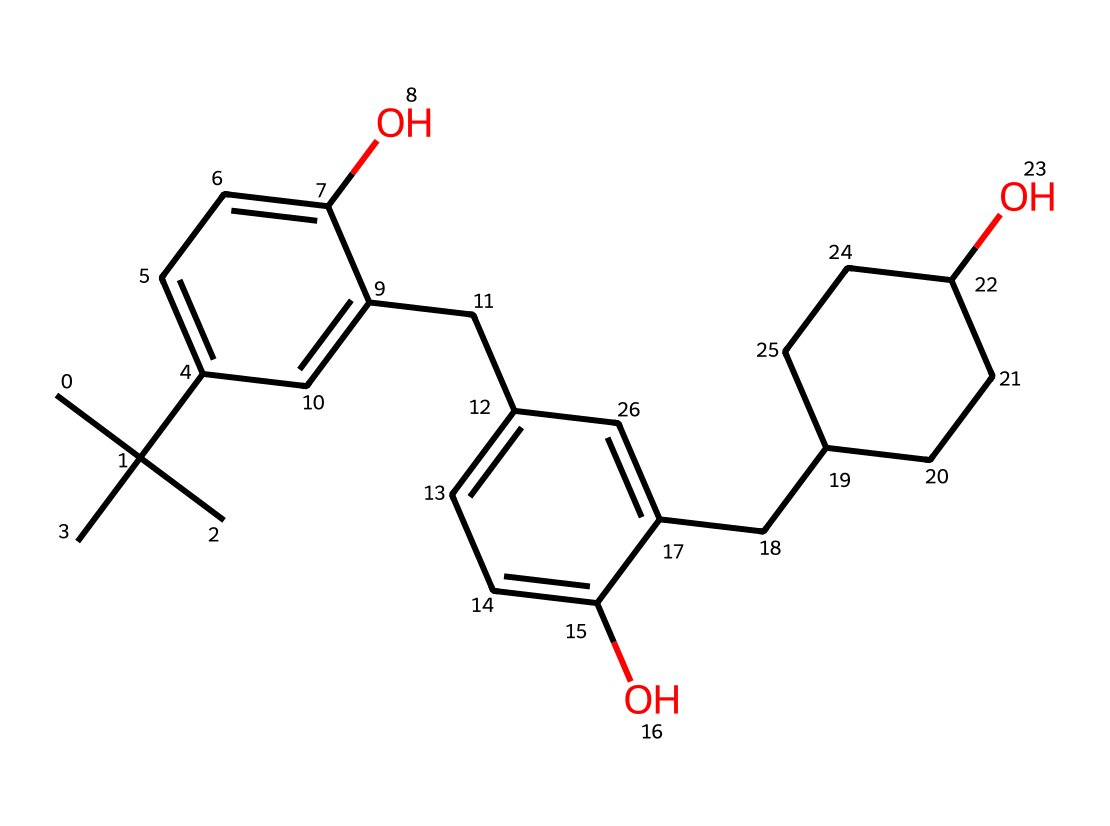What is the total number of carbon atoms in this chemical structure? By counting the number of carbon atoms present in the chemical structure representation, we can identify that there are a total of 20 carbon atoms.
Answer: 20 What type of functional groups are present in this photoresist? The chemical contains hydroxyl (-OH) groups, indicated by the presence of oxygen atoms connected to hydrogen atoms in the structure.
Answer: hydroxyl How many benzene rings are present in this chemical structure? Upon analyzing the structure, we observe two distinct phenyl groups (benzene rings), each represented by a six-membered carbon ring with alternating double bonds.
Answer: 2 Which part of the chemical structure is responsible for its solubility characteristics? The presence of hydroxyl (-OH) groups contributes to the chemical's ability to dissolve in polar solvents, typically due to hydrogen bonding with solvents.
Answer: hydroxyl groups What is the molecular weight of the compound represented by this SMILES? To determine the molecular weight, we can calculate the contributions of all atoms as follows: carbon (12.01 g/mol), hydrogen (1.008 g/mol), and oxygen (16.00 g/mol). The total weight for this compound is calculated to be approximately 302.36 g/mol.
Answer: 302.36 What makes this photoresist suitable for printing applications? The presence of functional groups, particularly hydroxyl groups, assists in the photo-crosslinking process vital for creating stable images on comic book covers when exposed to light.
Answer: photo-crosslinking capabilities 